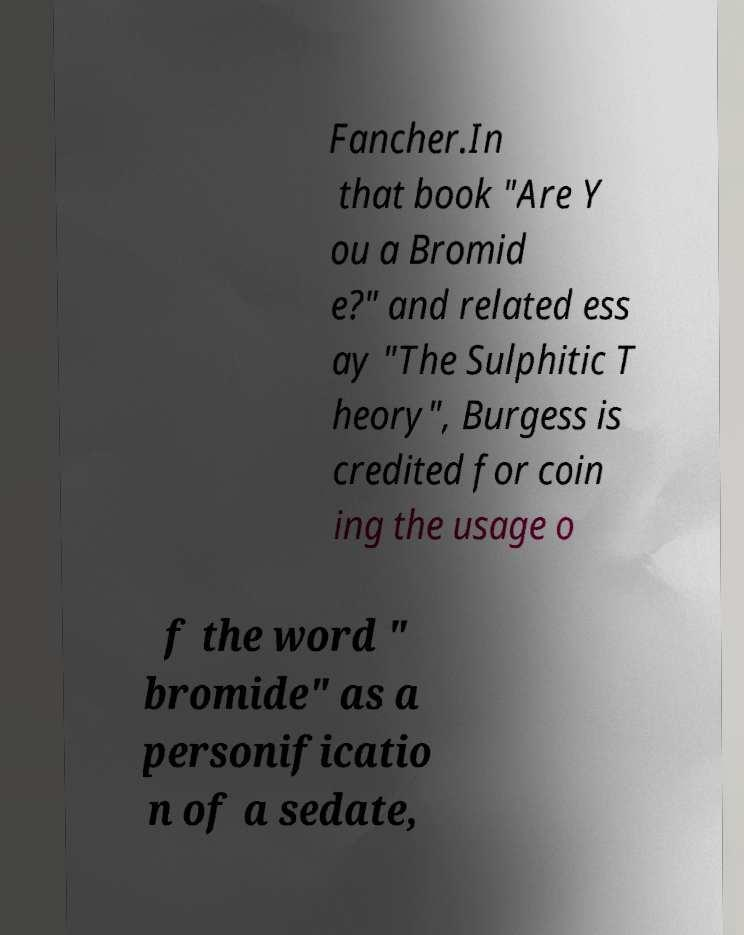I need the written content from this picture converted into text. Can you do that? Fancher.In that book "Are Y ou a Bromid e?" and related ess ay "The Sulphitic T heory", Burgess is credited for coin ing the usage o f the word " bromide" as a personificatio n of a sedate, 